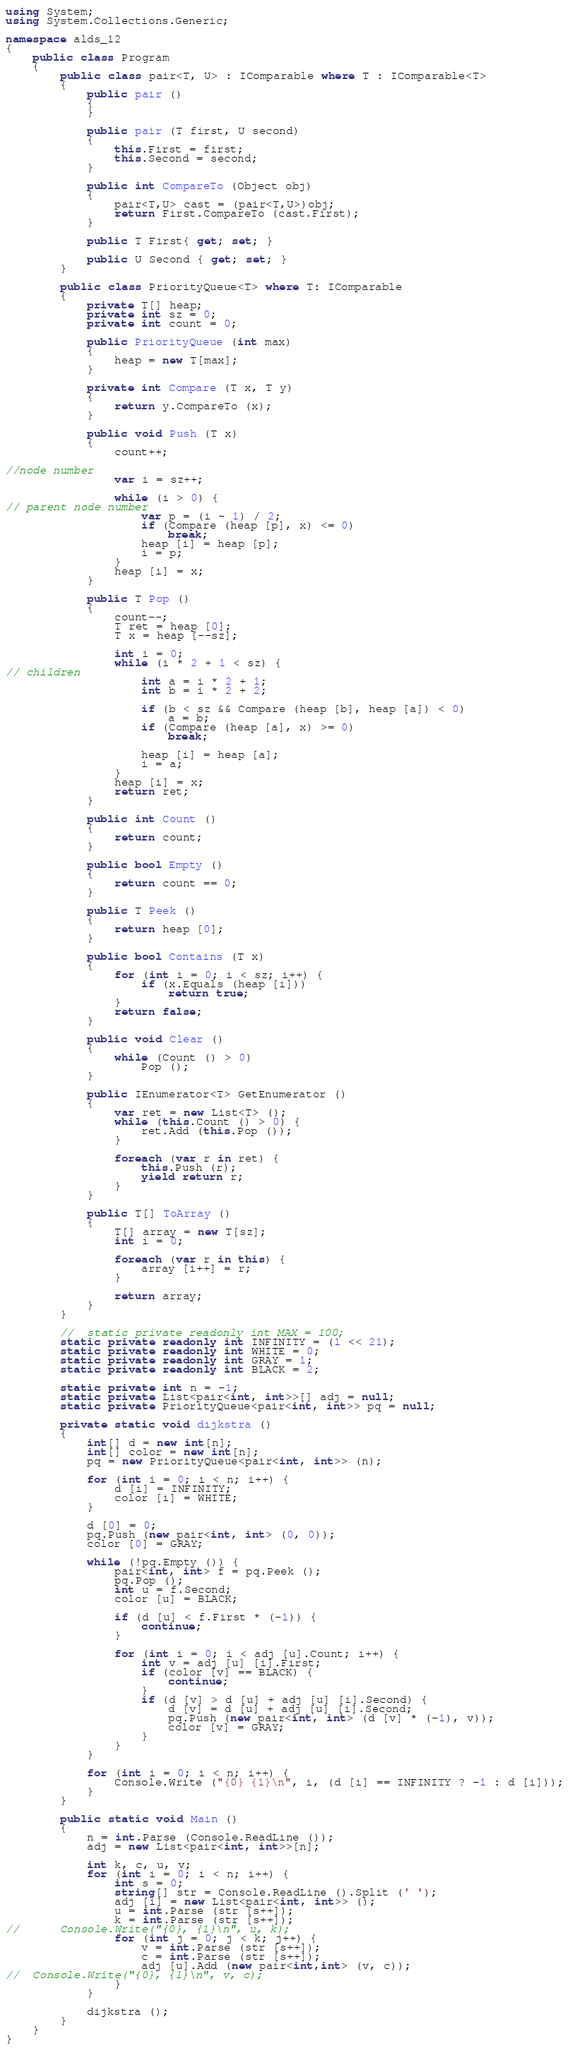<code> <loc_0><loc_0><loc_500><loc_500><_C#_>using System;
using System.Collections.Generic;

namespace alds_12
{
	public class Program
	{
		public class pair<T, U> : IComparable where T : IComparable<T>
		{
			public pair ()
			{
			}

			public pair (T first, U second)
			{
				this.First = first;
				this.Second = second;
			}

			public int CompareTo (Object obj)
			{
				pair<T,U> cast = (pair<T,U>)obj;
				return First.CompareTo (cast.First);
			}

			public T First{ get; set; }

			public U Second { get; set; }
		}

		public class PriorityQueue<T> where T: IComparable
		{
			private T[] heap;
			private int sz = 0;
			private int count = 0;

			public PriorityQueue (int max)
			{
				heap = new T[max];
			}

			private int Compare (T x, T y)
			{
				return y.CompareTo (x);
			}

			public void Push (T x)
			{
				count++;

//node number
				var i = sz++;

				while (i > 0) {
// parent node number
					var p = (i - 1) / 2;
					if (Compare (heap [p], x) <= 0)
						break;
					heap [i] = heap [p];
					i = p;
				}
				heap [i] = x;
			}

			public T Pop ()
			{
				count--;
				T ret = heap [0];
				T x = heap [--sz];

				int i = 0;
				while (i * 2 + 1 < sz) {
// children
					int a = i * 2 + 1;
					int b = i * 2 + 2;

					if (b < sz && Compare (heap [b], heap [a]) < 0)
						a = b;
					if (Compare (heap [a], x) >= 0)
						break;

					heap [i] = heap [a];
					i = a;
				}
				heap [i] = x;
				return ret;
			}

			public int Count ()
			{
				return count;
			}

			public bool Empty ()
			{
				return count == 0;
			}

			public T Peek ()
			{
				return heap [0];
			}

			public bool Contains (T x)
			{
				for (int i = 0; i < sz; i++) {
					if (x.Equals (heap [i]))
						return true;
				}
				return false;
			}

			public void Clear ()
			{
				while (Count () > 0)
					Pop ();
			}

			public IEnumerator<T> GetEnumerator ()
			{
				var ret = new List<T> ();
				while (this.Count () > 0) {
					ret.Add (this.Pop ());
				}

				foreach (var r in ret) {
					this.Push (r);
					yield return r;
				}
			}

			public T[] ToArray ()
			{
				T[] array = new T[sz];
				int i = 0;

				foreach (var r in this) {
					array [i++] = r;
				}

				return array;
			}
		}

		//  static private readonly int MAX = 100;
		static private readonly int INFINITY = (1 << 21);
		static private readonly int WHITE = 0;
		static private readonly int GRAY = 1;
		static private readonly int BLACK = 2;

		static private int n = -1;
		static private List<pair<int, int>>[] adj = null;
		static private PriorityQueue<pair<int, int>> pq = null;

		private static void dijkstra ()
		{
			int[] d = new int[n];
			int[] color = new int[n];
			pq = new PriorityQueue<pair<int, int>> (n);

			for (int i = 0; i < n; i++) {
				d [i] = INFINITY;
				color [i] = WHITE;
			}

			d [0] = 0;
			pq.Push (new pair<int, int> (0, 0));
			color [0] = GRAY;

			while (!pq.Empty ()) {
				pair<int, int> f = pq.Peek ();
				pq.Pop ();
				int u = f.Second;
				color [u] = BLACK;

				if (d [u] < f.First * (-1)) {
					continue;
				}

				for (int i = 0; i < adj [u].Count; i++) {
					int v = adj [u] [i].First;
					if (color [v] == BLACK) {
						continue;
					}
					if (d [v] > d [u] + adj [u] [i].Second) {
						d [v] = d [u] + adj [u] [i].Second;
						pq.Push (new pair<int, int> (d [v] * (-1), v));
						color [v] = GRAY;
					}
				}
			}

			for (int i = 0; i < n; i++) {
				Console.Write ("{0} {1}\n", i, (d [i] == INFINITY ? -1 : d [i]));
			}
		}

		public static void Main ()
		{
			n = int.Parse (Console.ReadLine ());
			adj = new List<pair<int, int>>[n];

			int k, c, u, v;
			for (int i = 0; i < n; i++) {
				int s = 0;
				string[] str = Console.ReadLine ().Split (' ');
				adj [i] = new List<pair<int, int>> ();
				u = int.Parse (str [s++]);
				k = int.Parse (str [s++]);
//      Console.Write("{0}, {1}\n", u, k);
				for (int j = 0; j < k; j++) {
					v = int.Parse (str [s++]);
					c = int.Parse (str [s++]);
					adj [u].Add (new pair<int,int> (v, c));
//	Console.Write("{0}, {1}\n", v, c);
				}
			}

			dijkstra ();
		}
	}
}</code> 